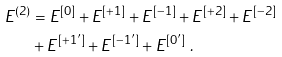<formula> <loc_0><loc_0><loc_500><loc_500>E ^ { ( 2 ) } & = E ^ { [ 0 ] } + E ^ { [ + 1 ] } + E ^ { [ - 1 ] } + E ^ { [ + 2 ] } + E ^ { [ - 2 ] } \\ & + E ^ { [ + 1 ^ { \prime } ] } + E ^ { [ - 1 ^ { \prime } ] } + E ^ { [ 0 ^ { \prime } ] } \ .</formula> 